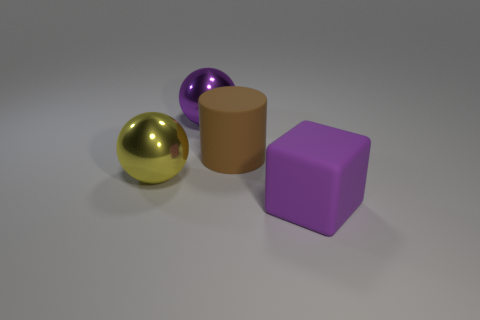Add 2 small gray balls. How many objects exist? 6 Subtract all cylinders. How many objects are left? 3 Subtract 0 cyan cylinders. How many objects are left? 4 Subtract all tiny brown rubber objects. Subtract all large brown cylinders. How many objects are left? 3 Add 3 brown rubber cylinders. How many brown rubber cylinders are left? 4 Add 4 big shiny things. How many big shiny things exist? 6 